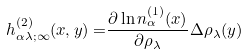Convert formula to latex. <formula><loc_0><loc_0><loc_500><loc_500>h _ { \alpha \lambda ; \infty } ^ { ( 2 ) } ( { x , y ) = } \frac { \partial \ln n _ { \alpha } ^ { ( 1 ) } ( { x } ) } { \partial \rho _ { \lambda } } \Delta \rho _ { \lambda } ( { y ) }</formula> 